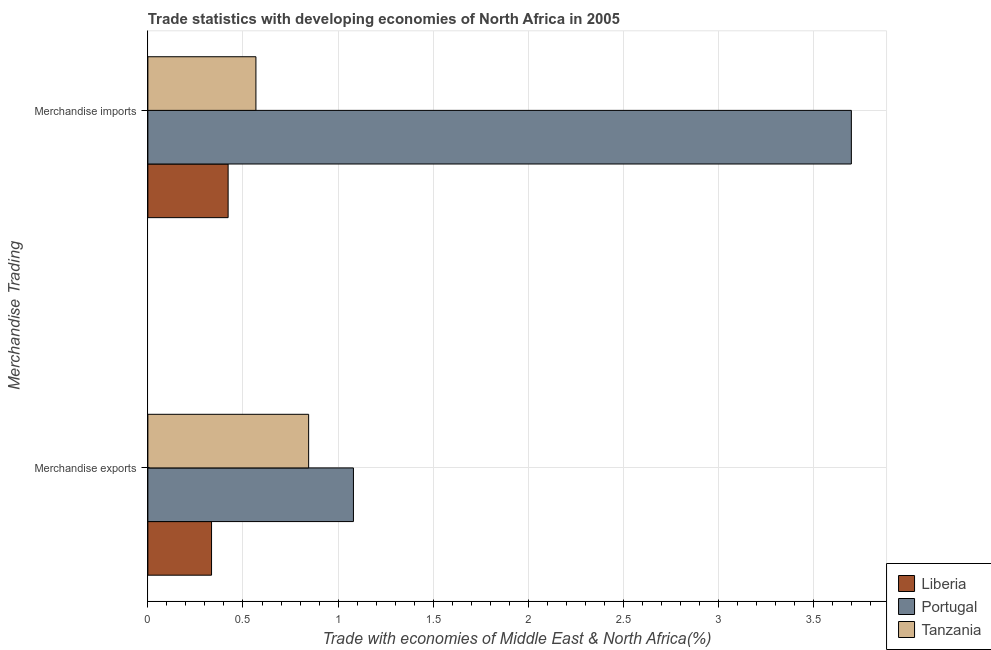Are the number of bars on each tick of the Y-axis equal?
Give a very brief answer. Yes. How many bars are there on the 1st tick from the top?
Keep it short and to the point. 3. What is the label of the 1st group of bars from the top?
Your response must be concise. Merchandise imports. What is the merchandise exports in Tanzania?
Your answer should be very brief. 0.85. Across all countries, what is the maximum merchandise exports?
Your response must be concise. 1.08. Across all countries, what is the minimum merchandise imports?
Provide a succinct answer. 0.42. In which country was the merchandise imports minimum?
Make the answer very short. Liberia. What is the total merchandise imports in the graph?
Make the answer very short. 4.69. What is the difference between the merchandise exports in Liberia and that in Portugal?
Keep it short and to the point. -0.75. What is the difference between the merchandise imports in Liberia and the merchandise exports in Tanzania?
Provide a short and direct response. -0.42. What is the average merchandise imports per country?
Ensure brevity in your answer.  1.56. What is the difference between the merchandise imports and merchandise exports in Portugal?
Your response must be concise. 2.62. What is the ratio of the merchandise imports in Tanzania to that in Liberia?
Your response must be concise. 1.35. Is the merchandise exports in Portugal less than that in Liberia?
Offer a very short reply. No. In how many countries, is the merchandise imports greater than the average merchandise imports taken over all countries?
Your response must be concise. 1. What does the 1st bar from the top in Merchandise imports represents?
Ensure brevity in your answer.  Tanzania. What does the 1st bar from the bottom in Merchandise imports represents?
Offer a terse response. Liberia. How many bars are there?
Provide a succinct answer. 6. How many countries are there in the graph?
Your answer should be very brief. 3. Where does the legend appear in the graph?
Your answer should be very brief. Bottom right. How are the legend labels stacked?
Keep it short and to the point. Vertical. What is the title of the graph?
Your response must be concise. Trade statistics with developing economies of North Africa in 2005. Does "Bolivia" appear as one of the legend labels in the graph?
Offer a terse response. No. What is the label or title of the X-axis?
Your answer should be compact. Trade with economies of Middle East & North Africa(%). What is the label or title of the Y-axis?
Provide a short and direct response. Merchandise Trading. What is the Trade with economies of Middle East & North Africa(%) of Liberia in Merchandise exports?
Make the answer very short. 0.33. What is the Trade with economies of Middle East & North Africa(%) in Portugal in Merchandise exports?
Ensure brevity in your answer.  1.08. What is the Trade with economies of Middle East & North Africa(%) in Tanzania in Merchandise exports?
Your answer should be very brief. 0.85. What is the Trade with economies of Middle East & North Africa(%) in Liberia in Merchandise imports?
Offer a terse response. 0.42. What is the Trade with economies of Middle East & North Africa(%) in Portugal in Merchandise imports?
Your answer should be compact. 3.7. What is the Trade with economies of Middle East & North Africa(%) in Tanzania in Merchandise imports?
Give a very brief answer. 0.57. Across all Merchandise Trading, what is the maximum Trade with economies of Middle East & North Africa(%) in Liberia?
Ensure brevity in your answer.  0.42. Across all Merchandise Trading, what is the maximum Trade with economies of Middle East & North Africa(%) of Portugal?
Provide a short and direct response. 3.7. Across all Merchandise Trading, what is the maximum Trade with economies of Middle East & North Africa(%) of Tanzania?
Provide a succinct answer. 0.85. Across all Merchandise Trading, what is the minimum Trade with economies of Middle East & North Africa(%) in Liberia?
Your answer should be compact. 0.33. Across all Merchandise Trading, what is the minimum Trade with economies of Middle East & North Africa(%) of Portugal?
Give a very brief answer. 1.08. Across all Merchandise Trading, what is the minimum Trade with economies of Middle East & North Africa(%) in Tanzania?
Offer a terse response. 0.57. What is the total Trade with economies of Middle East & North Africa(%) in Liberia in the graph?
Your answer should be very brief. 0.76. What is the total Trade with economies of Middle East & North Africa(%) in Portugal in the graph?
Give a very brief answer. 4.78. What is the total Trade with economies of Middle East & North Africa(%) in Tanzania in the graph?
Ensure brevity in your answer.  1.41. What is the difference between the Trade with economies of Middle East & North Africa(%) of Liberia in Merchandise exports and that in Merchandise imports?
Offer a very short reply. -0.09. What is the difference between the Trade with economies of Middle East & North Africa(%) of Portugal in Merchandise exports and that in Merchandise imports?
Ensure brevity in your answer.  -2.62. What is the difference between the Trade with economies of Middle East & North Africa(%) in Tanzania in Merchandise exports and that in Merchandise imports?
Provide a short and direct response. 0.28. What is the difference between the Trade with economies of Middle East & North Africa(%) in Liberia in Merchandise exports and the Trade with economies of Middle East & North Africa(%) in Portugal in Merchandise imports?
Make the answer very short. -3.36. What is the difference between the Trade with economies of Middle East & North Africa(%) of Liberia in Merchandise exports and the Trade with economies of Middle East & North Africa(%) of Tanzania in Merchandise imports?
Give a very brief answer. -0.23. What is the difference between the Trade with economies of Middle East & North Africa(%) of Portugal in Merchandise exports and the Trade with economies of Middle East & North Africa(%) of Tanzania in Merchandise imports?
Keep it short and to the point. 0.51. What is the average Trade with economies of Middle East & North Africa(%) of Liberia per Merchandise Trading?
Provide a succinct answer. 0.38. What is the average Trade with economies of Middle East & North Africa(%) in Portugal per Merchandise Trading?
Your response must be concise. 2.39. What is the average Trade with economies of Middle East & North Africa(%) in Tanzania per Merchandise Trading?
Your answer should be compact. 0.71. What is the difference between the Trade with economies of Middle East & North Africa(%) in Liberia and Trade with economies of Middle East & North Africa(%) in Portugal in Merchandise exports?
Your answer should be compact. -0.75. What is the difference between the Trade with economies of Middle East & North Africa(%) of Liberia and Trade with economies of Middle East & North Africa(%) of Tanzania in Merchandise exports?
Offer a very short reply. -0.51. What is the difference between the Trade with economies of Middle East & North Africa(%) in Portugal and Trade with economies of Middle East & North Africa(%) in Tanzania in Merchandise exports?
Make the answer very short. 0.24. What is the difference between the Trade with economies of Middle East & North Africa(%) in Liberia and Trade with economies of Middle East & North Africa(%) in Portugal in Merchandise imports?
Offer a terse response. -3.28. What is the difference between the Trade with economies of Middle East & North Africa(%) in Liberia and Trade with economies of Middle East & North Africa(%) in Tanzania in Merchandise imports?
Provide a short and direct response. -0.15. What is the difference between the Trade with economies of Middle East & North Africa(%) in Portugal and Trade with economies of Middle East & North Africa(%) in Tanzania in Merchandise imports?
Make the answer very short. 3.13. What is the ratio of the Trade with economies of Middle East & North Africa(%) of Liberia in Merchandise exports to that in Merchandise imports?
Offer a very short reply. 0.79. What is the ratio of the Trade with economies of Middle East & North Africa(%) of Portugal in Merchandise exports to that in Merchandise imports?
Provide a short and direct response. 0.29. What is the ratio of the Trade with economies of Middle East & North Africa(%) in Tanzania in Merchandise exports to that in Merchandise imports?
Give a very brief answer. 1.49. What is the difference between the highest and the second highest Trade with economies of Middle East & North Africa(%) of Liberia?
Your answer should be compact. 0.09. What is the difference between the highest and the second highest Trade with economies of Middle East & North Africa(%) in Portugal?
Your answer should be very brief. 2.62. What is the difference between the highest and the second highest Trade with economies of Middle East & North Africa(%) of Tanzania?
Offer a very short reply. 0.28. What is the difference between the highest and the lowest Trade with economies of Middle East & North Africa(%) of Liberia?
Offer a terse response. 0.09. What is the difference between the highest and the lowest Trade with economies of Middle East & North Africa(%) of Portugal?
Offer a very short reply. 2.62. What is the difference between the highest and the lowest Trade with economies of Middle East & North Africa(%) of Tanzania?
Make the answer very short. 0.28. 